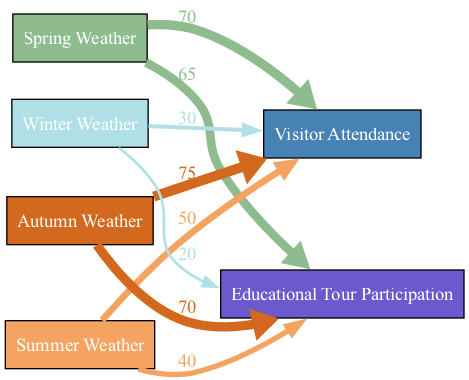What is the highest value for Visitor Attendance? By examining the connections from each weather type to Visitor Attendance, I see that Autumn Weather has the highest value of 75.
Answer: 75 What is the lowest value for Educational Tour Participation? Looking at the connections for Educational Tour Participation, the lowest value is 20, which corresponds to Winter Weather.
Answer: 20 Which season contributes the most to Educational Tour Participation? Comparing the values of Educational Tour Participation across all seasons, Autumn Weather contributes the most with a value of 70.
Answer: Autumn Weather How many connections are there in total? To find the total connections, I count each connection listed in the data. There are 8 connections between the seasons and the two types of participation.
Answer: 8 What is the total value of Visitor Attendance in Summer Weather? Only the connection related to Summer Weather indicates that the value for Visitor Attendance is 50.
Answer: 50 Which season has the least impact on Visitor Attendance? I check the values of Visitor Attendance for each weather type and find that Winter Weather has the least impact with a value of 30.
Answer: Winter Weather What percentage of Educational Tour Participation comes from Spring Weather compared to Autumn Weather? The values for Spring Weather and Autumn Weather are 65 and 70, respectively. The percentage from Spring Weather is (65 / 70) * 100 = 92.86%.
Answer: 92.86% Which weather type has the same effect on Visitor Attendance and Educational Tour Participation? By analyzing the connections, Summer Weather shows the least effect on both metrics, contributing 50 for Visitor Attendance and 40 for Educational Tour Participation.
Answer: Summer Weather What do the colors signify in the diagram? The colors in the diagram represent different weather types and their corresponding effects on Visitor Attendance and Educational Tour Participation. Each season is a unique color.
Answer: Different weather types 